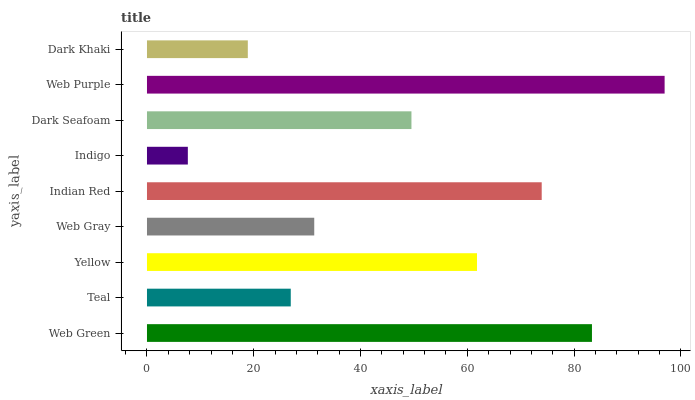Is Indigo the minimum?
Answer yes or no. Yes. Is Web Purple the maximum?
Answer yes or no. Yes. Is Teal the minimum?
Answer yes or no. No. Is Teal the maximum?
Answer yes or no. No. Is Web Green greater than Teal?
Answer yes or no. Yes. Is Teal less than Web Green?
Answer yes or no. Yes. Is Teal greater than Web Green?
Answer yes or no. No. Is Web Green less than Teal?
Answer yes or no. No. Is Dark Seafoam the high median?
Answer yes or no. Yes. Is Dark Seafoam the low median?
Answer yes or no. Yes. Is Yellow the high median?
Answer yes or no. No. Is Teal the low median?
Answer yes or no. No. 